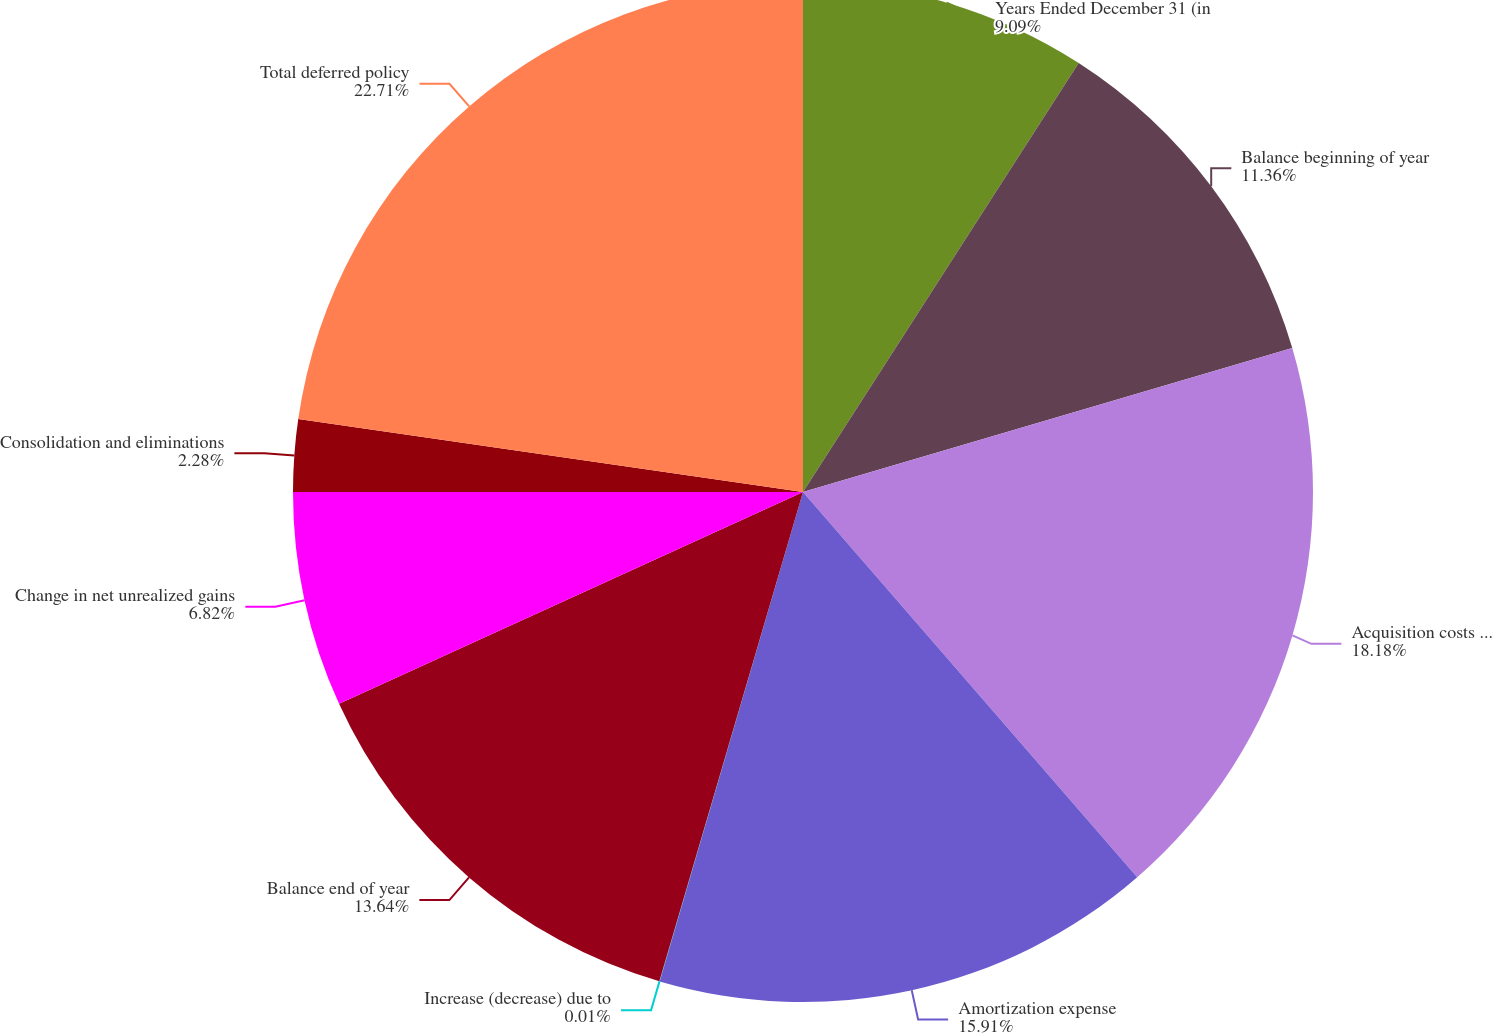Convert chart to OTSL. <chart><loc_0><loc_0><loc_500><loc_500><pie_chart><fcel>Years Ended December 31 (in<fcel>Balance beginning of year<fcel>Acquisition costs deferred<fcel>Amortization expense<fcel>Increase (decrease) due to<fcel>Balance end of year<fcel>Change in net unrealized gains<fcel>Consolidation and eliminations<fcel>Total deferred policy<nl><fcel>9.09%<fcel>11.36%<fcel>18.18%<fcel>15.91%<fcel>0.01%<fcel>13.64%<fcel>6.82%<fcel>2.28%<fcel>22.72%<nl></chart> 